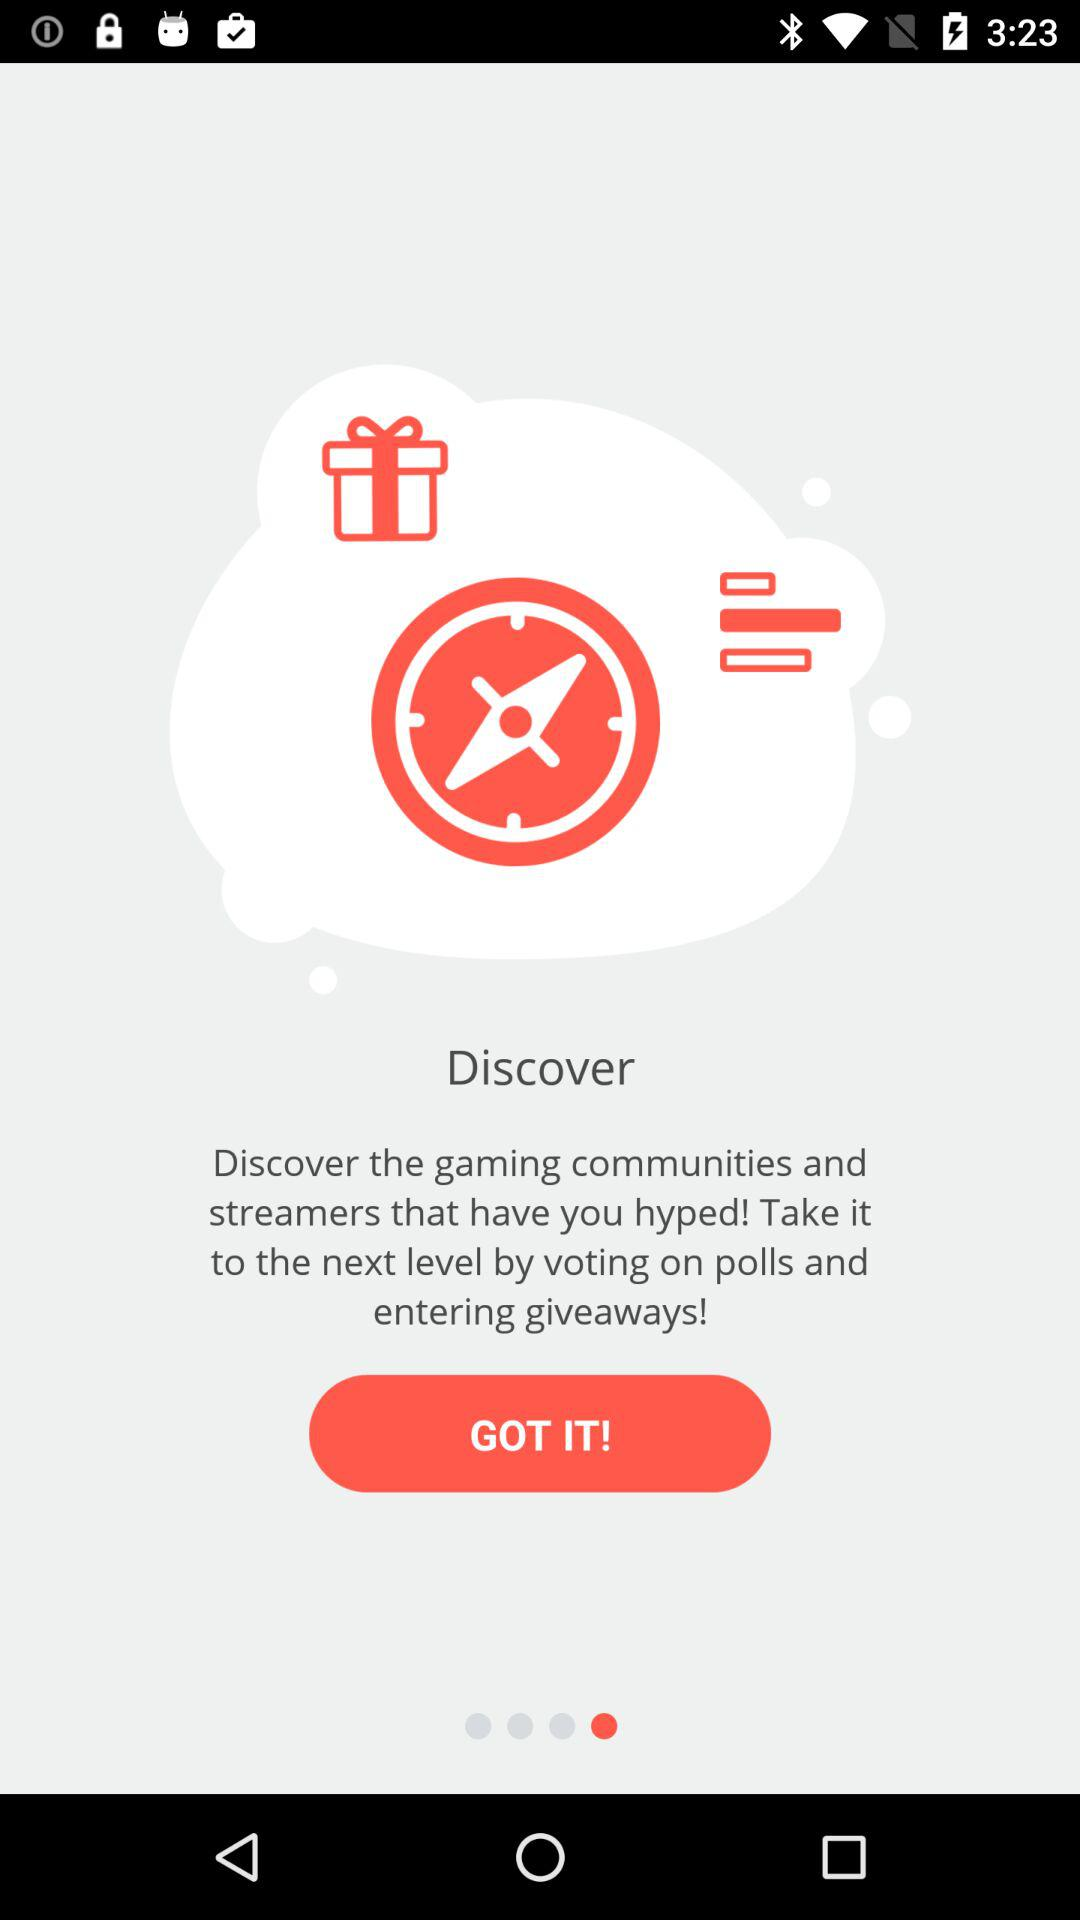What is the name of the application? The application name is "Discover". 